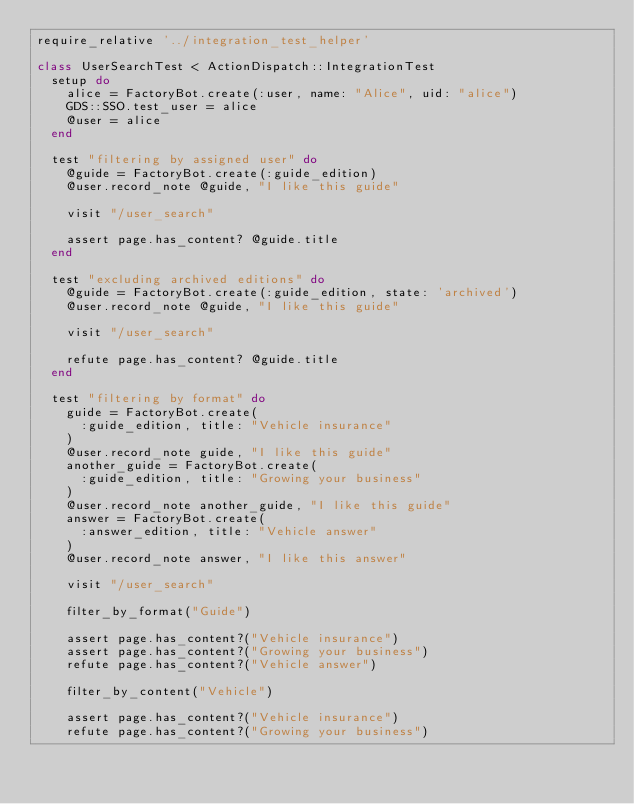<code> <loc_0><loc_0><loc_500><loc_500><_Ruby_>require_relative '../integration_test_helper'

class UserSearchTest < ActionDispatch::IntegrationTest
  setup do
    alice = FactoryBot.create(:user, name: "Alice", uid: "alice")
    GDS::SSO.test_user = alice
    @user = alice
  end

  test "filtering by assigned user" do
    @guide = FactoryBot.create(:guide_edition)
    @user.record_note @guide, "I like this guide"

    visit "/user_search"

    assert page.has_content? @guide.title
  end

  test "excluding archived editions" do
    @guide = FactoryBot.create(:guide_edition, state: 'archived')
    @user.record_note @guide, "I like this guide"

    visit "/user_search"

    refute page.has_content? @guide.title
  end

  test "filtering by format" do
    guide = FactoryBot.create(
      :guide_edition, title: "Vehicle insurance"
    )
    @user.record_note guide, "I like this guide"
    another_guide = FactoryBot.create(
      :guide_edition, title: "Growing your business"
    )
    @user.record_note another_guide, "I like this guide"
    answer = FactoryBot.create(
      :answer_edition, title: "Vehicle answer"
    )
    @user.record_note answer, "I like this answer"

    visit "/user_search"

    filter_by_format("Guide")

    assert page.has_content?("Vehicle insurance")
    assert page.has_content?("Growing your business")
    refute page.has_content?("Vehicle answer")

    filter_by_content("Vehicle")

    assert page.has_content?("Vehicle insurance")
    refute page.has_content?("Growing your business")</code> 